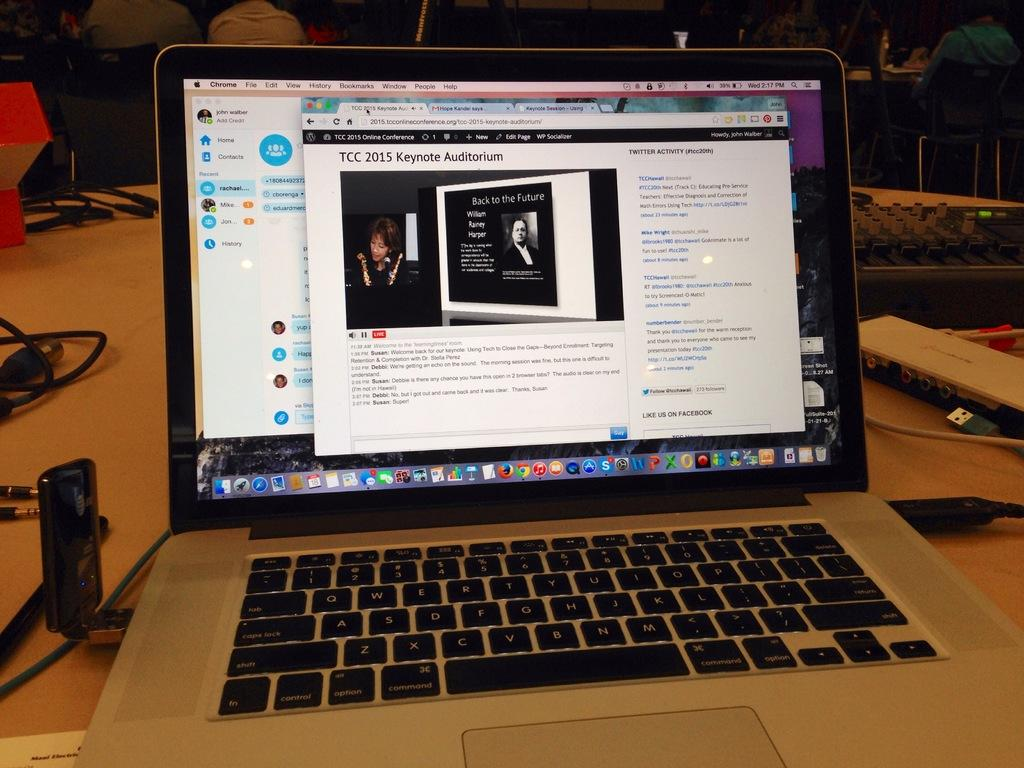<image>
Offer a succinct explanation of the picture presented. Laptop screen that says TCC 2015 Keynote Auditorium, with the words back to the future, William, Rainey, Harper. 